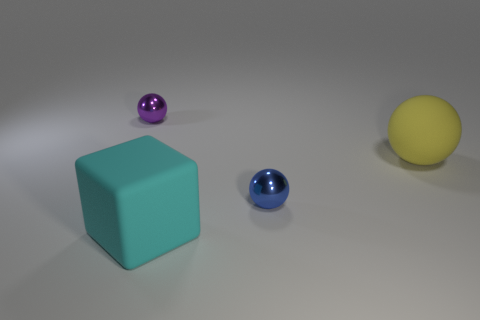Subtract all spheres. How many objects are left? 1 Subtract all blue spheres. How many spheres are left? 2 Subtract all yellow matte balls. How many balls are left? 2 Subtract 1 purple balls. How many objects are left? 3 Subtract 3 spheres. How many spheres are left? 0 Subtract all brown balls. Subtract all yellow cubes. How many balls are left? 3 Subtract all green cylinders. How many yellow balls are left? 1 Subtract all tiny blue shiny things. Subtract all blue shiny cylinders. How many objects are left? 3 Add 1 large cyan cubes. How many large cyan cubes are left? 2 Add 3 rubber cubes. How many rubber cubes exist? 4 